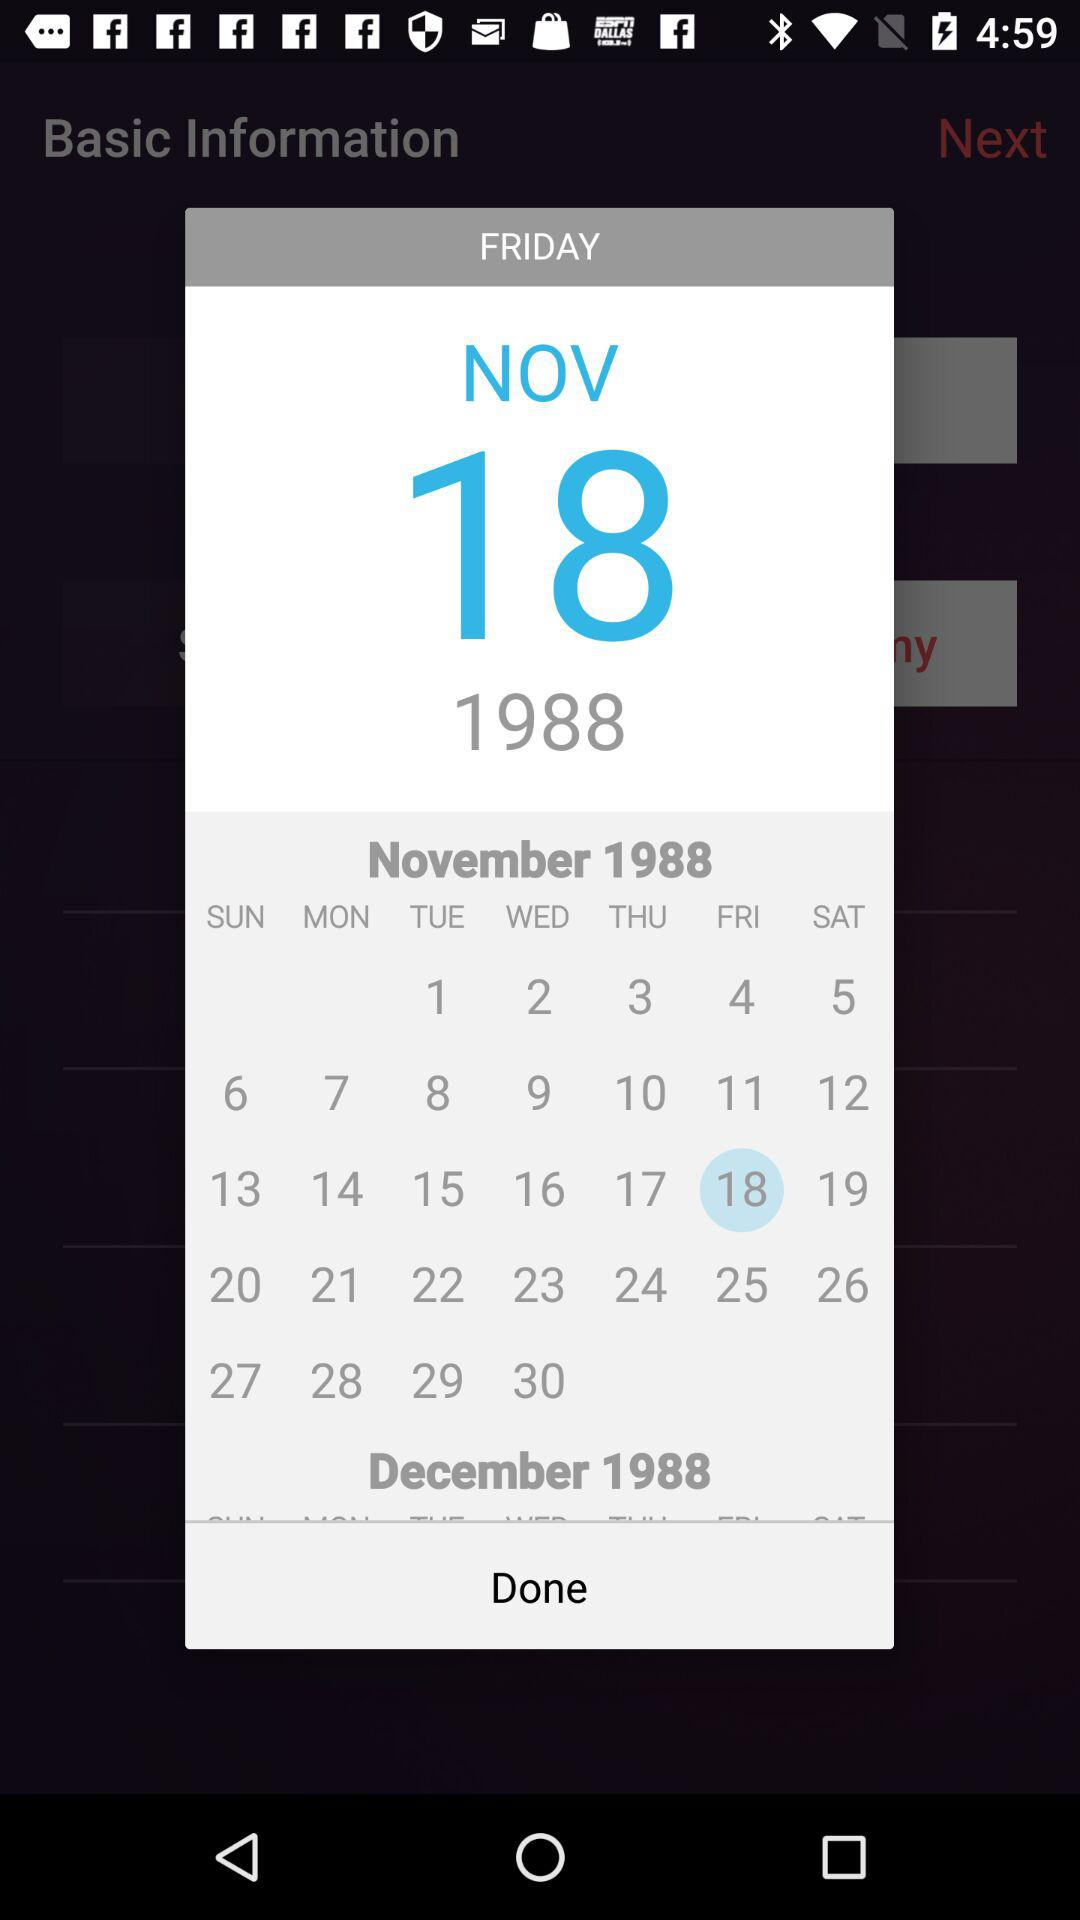What is the selected date? The selected date is Friday, November 18, 1988. 